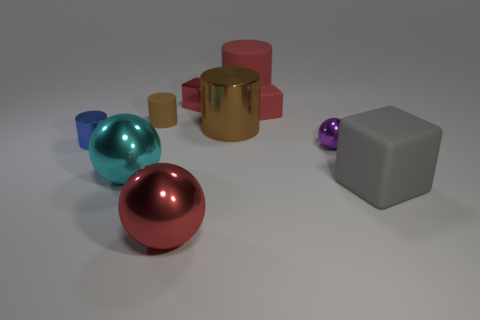Subtract all cubes. How many objects are left? 7 Subtract all big things. Subtract all red matte things. How many objects are left? 3 Add 1 tiny metal spheres. How many tiny metal spheres are left? 2 Add 2 small brown matte things. How many small brown matte things exist? 3 Subtract 1 red spheres. How many objects are left? 9 